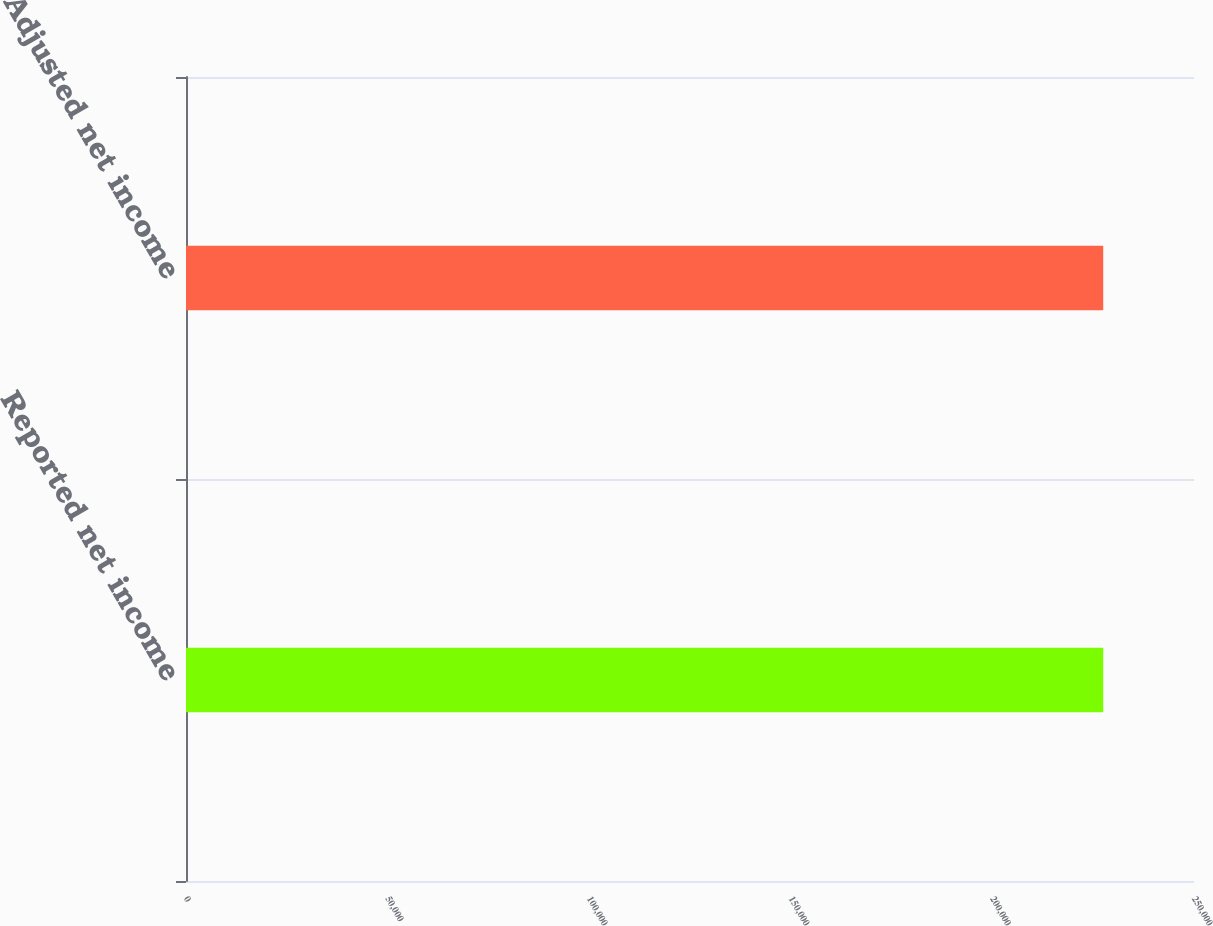Convert chart. <chart><loc_0><loc_0><loc_500><loc_500><bar_chart><fcel>Reported net income<fcel>Adjusted net income<nl><fcel>227487<fcel>227487<nl></chart> 